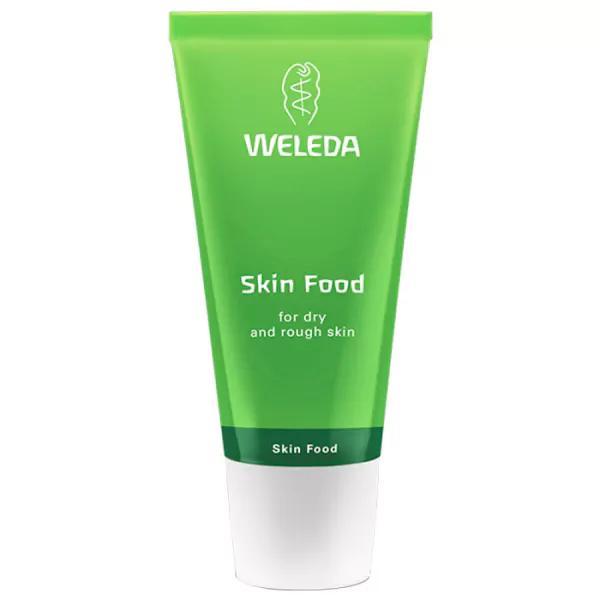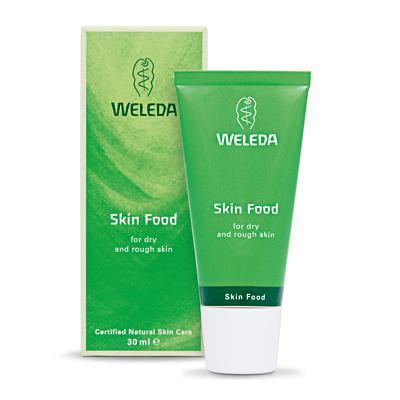The first image is the image on the left, the second image is the image on the right. For the images displayed, is the sentence "In at least one image, there is a green tube with a white cap next to a green box packaging" factually correct? Answer yes or no. Yes. The first image is the image on the left, the second image is the image on the right. Assess this claim about the two images: "Two tubes of body moisturing products are stood on cap end, one in each image, one of them beside a box in which the product may be sold.". Correct or not? Answer yes or no. Yes. 